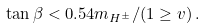Convert formula to latex. <formula><loc_0><loc_0><loc_500><loc_500>\tan \beta < 0 . 5 4 m _ { H ^ { \pm } } / ( 1 \geq v ) \, .</formula> 